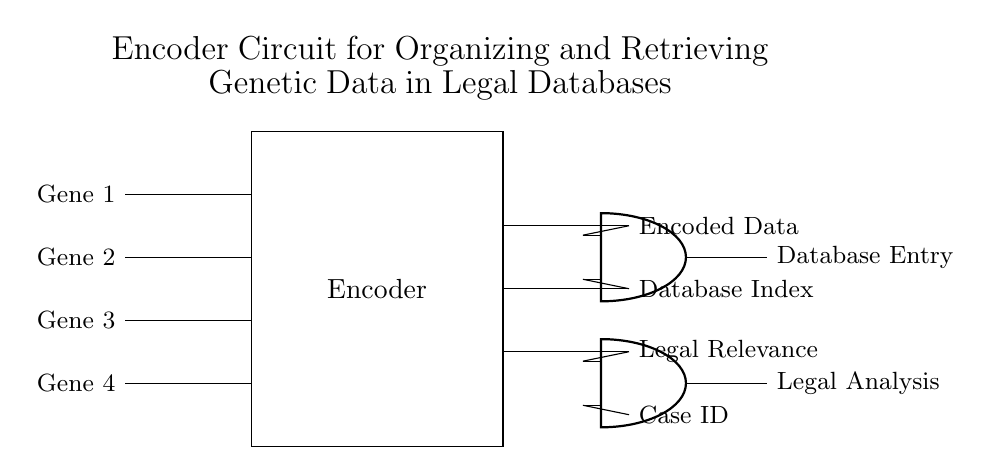What are the input variables for the encoder? The input variables are Gene 1, Gene 2, Gene 3, and Gene 4, as indicated on the left side of the circuit diagram.
Answer: Gene 1, Gene 2, Gene 3, Gene 4 What does the encoder output? The encoder outputs Encoded Data, Database Index, and Legal Relevance, which are specified on the right side of the circuit diagram.
Answer: Encoded Data, Database Index, Legal Relevance What type of logic gates are used in this circuit? The circuit contains AND gates, which are represented in the diagram. Therefore, the specific logic gate type is AND.
Answer: AND How many outputs does this encoder circuit have? The circuit has three outputs listed adjacent to the output lines, making it easy to quantify the outputs directly from the visual representation.
Answer: Three What is the significance of the Case ID in the circuit? The Case ID is an input to one of the AND gates, indicating its role in relation to the other data being processed within the circuit, specifically for the Legal Analysis output.
Answer: Input to AND gate What is the connection between the outputs and the AND gates? The outputs are connected to the respective inputs of the AND gates, showing how encoded data, database index, and legal relevance are processed further in the circuit for specific outputs.
Answer: All outputs connect to AND gates 